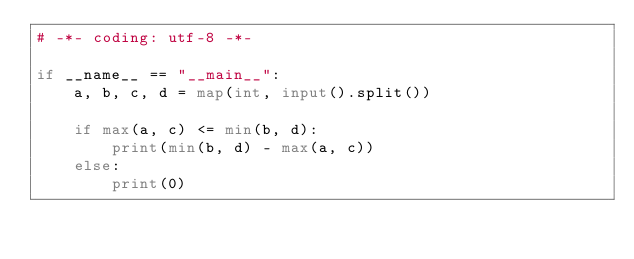Convert code to text. <code><loc_0><loc_0><loc_500><loc_500><_Python_># -*- coding: utf-8 -*-

if __name__ == "__main__":
    a, b, c, d = map(int, input().split())

    if max(a, c) <= min(b, d):
        print(min(b, d) - max(a, c))
    else:
        print(0)
</code> 